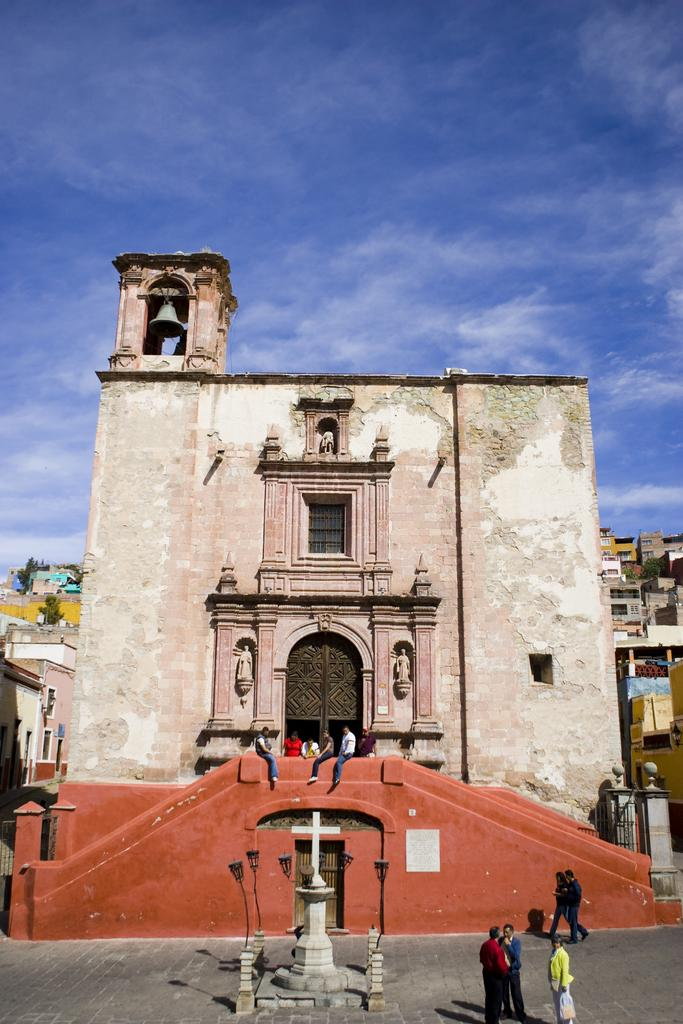Who or what can be seen in the image? There are people in the image. What can be seen in the distance behind the people? There are buildings, trees, and the sky visible in the background of the image. How many feathers can be seen floating in the sky in the image? There are no feathers visible in the image; only people, buildings, trees, and the sky can be seen. 